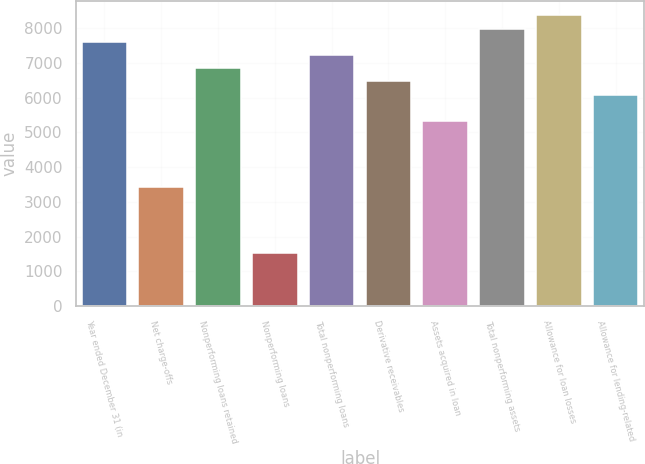Convert chart. <chart><loc_0><loc_0><loc_500><loc_500><bar_chart><fcel>Year ended December 31 (in<fcel>Net charge-offs<fcel>Nonperforming loans retained<fcel>Nonperforming loans<fcel>Total nonperforming loans<fcel>Derivative receivables<fcel>Assets acquired in loan<fcel>Total nonperforming assets<fcel>Allowance for loan losses<fcel>Allowance for lending-related<nl><fcel>7607.94<fcel>3423.65<fcel>6847.16<fcel>1521.7<fcel>7227.55<fcel>6466.77<fcel>5325.6<fcel>7988.33<fcel>8368.72<fcel>6086.38<nl></chart> 